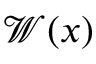Convert formula to latex. <formula><loc_0><loc_0><loc_500><loc_500>\mathcal { W } ( x )</formula> 